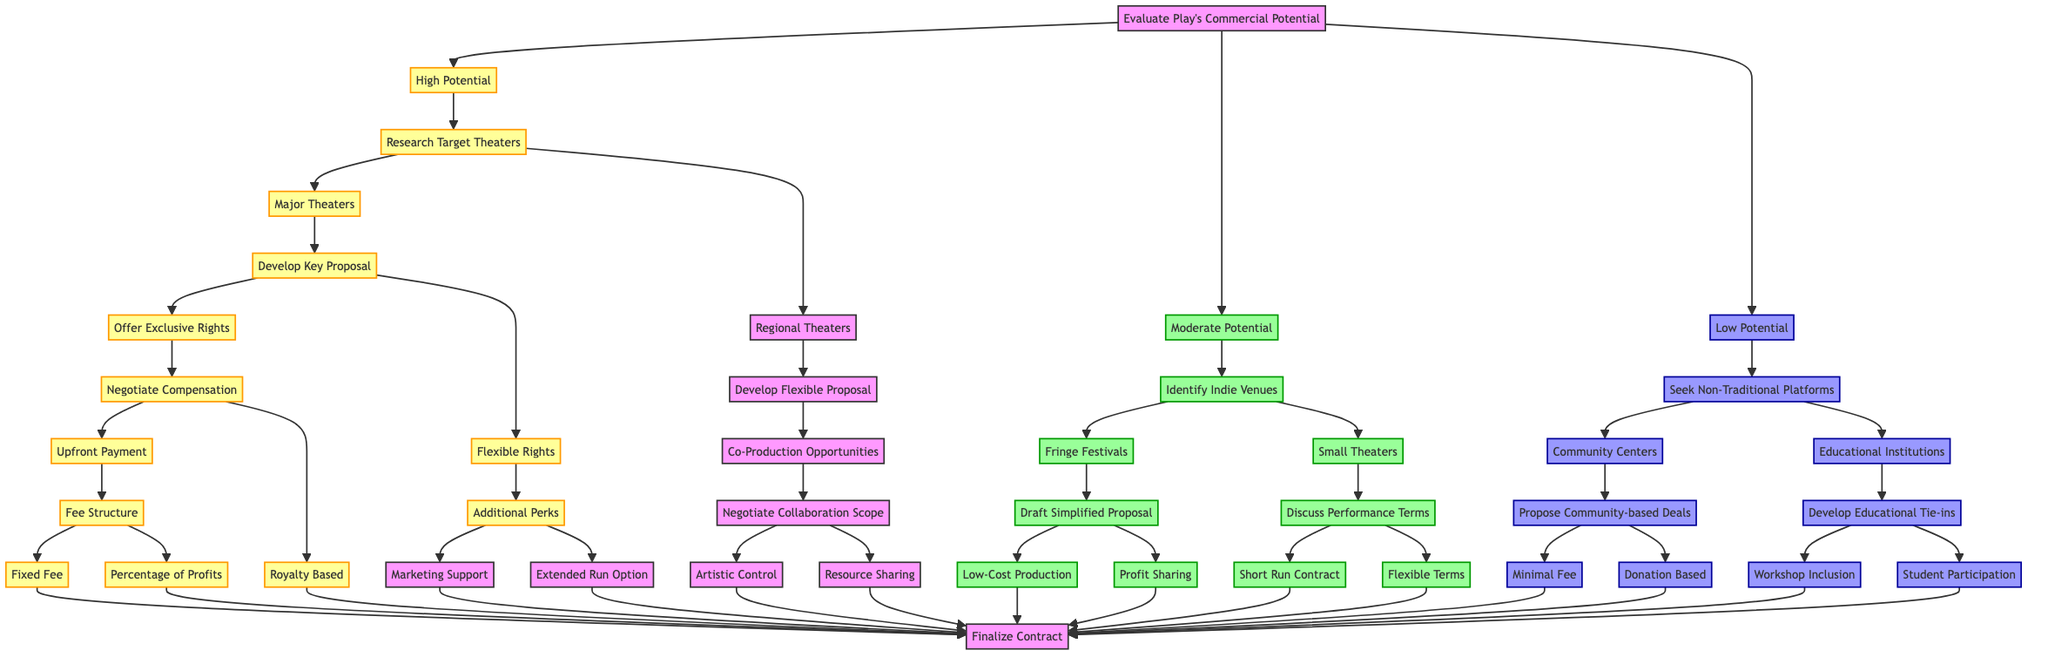What is the first decision point in the diagram? The first decision point is "Evaluate Play's Commercial Potential," which serves as the starting node that determines the subsequent paths based on the potential of the play.
Answer: Evaluate Play's Commercial Potential How many potential outcomes lead from "High Potential"? From "High Potential", there are 2 outcomes: "Research Target Theaters" and "Additional Perks." Therefore, branching from "High Potential," there are multiple next steps under "Research Target Theaters" leading to further decisions.
Answer: 2 Which theaters are identified under "Moderate Potential"? Under "Moderate Potential", the theaters identified are "Indie Venues," which are further divided into "Fringe Festivals" and "Small Theaters."
Answer: Indie Venues What are the two types of rights offered in the "Develop Key Proposal"? The two types of rights in the "Develop Key Proposal" are "Exclusive Rights" and "Flexible Rights." Each option branches into different negotiation strategies.
Answer: Exclusive Rights, Flexible Rights What type of deals are proposed under "Seek Non-Traditional Platforms"? Under "Seek Non-Traditional Platforms," the deals proposed include "Community-based Deals" and "Educational Tie-ins," highlighting alternative platforms for potential negotiations.
Answer: Community-based Deals, Educational Tie-ins How many final contract outcomes are possible under "High Potential"? Under "High Potential", there are 6 final contract outcomes following the different pathways derived from it, including fixed fee and royalty-based contracts.
Answer: 6 What follows after "Negotiate Compensation" if "Royalty Based" is chosen? If "Royalty Based" is chosen after "Negotiate Compensation," the next step is to "Finalize Contract," which indicates a direct path to concluding the negotiation without further steps.
Answer: Finalize Contract Explain the next step after selecting "Co-Production Opportunities." After selecting "Co-Production Opportunities," the next step is to "Negotiate Collaboration Scope," enabling a discussion on how the collaboration will be structured and what areas will be covered.
Answer: Negotiate Collaboration Scope What options are available under "Additional Perks"? Under "Additional Perks," the available options are "Marketing Support" and "Extended Run Option," which could enhance the contract's attractiveness and potential success.
Answer: Marketing Support, Extended Run Option What is the outcome if one chooses "Minimal Fee"? Choosing "Minimal Fee" under the "Propose Community-based Deals" leads directly to the "Finalize Contract" stage, indicating a simple conclusion to the negotiation process based on minimal financial commitment.
Answer: Finalize Contract 